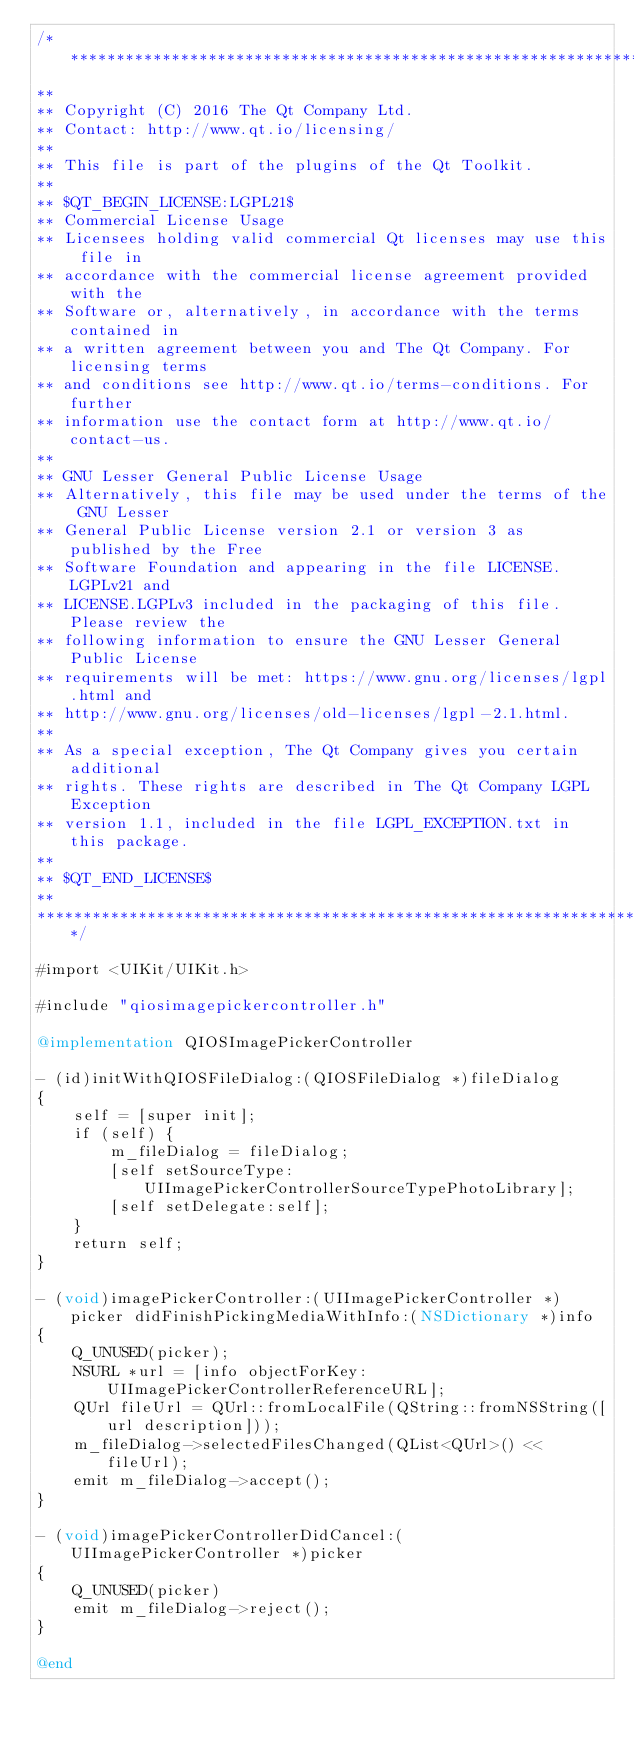<code> <loc_0><loc_0><loc_500><loc_500><_ObjectiveC_>/****************************************************************************
**
** Copyright (C) 2016 The Qt Company Ltd.
** Contact: http://www.qt.io/licensing/
**
** This file is part of the plugins of the Qt Toolkit.
**
** $QT_BEGIN_LICENSE:LGPL21$
** Commercial License Usage
** Licensees holding valid commercial Qt licenses may use this file in
** accordance with the commercial license agreement provided with the
** Software or, alternatively, in accordance with the terms contained in
** a written agreement between you and The Qt Company. For licensing terms
** and conditions see http://www.qt.io/terms-conditions. For further
** information use the contact form at http://www.qt.io/contact-us.
**
** GNU Lesser General Public License Usage
** Alternatively, this file may be used under the terms of the GNU Lesser
** General Public License version 2.1 or version 3 as published by the Free
** Software Foundation and appearing in the file LICENSE.LGPLv21 and
** LICENSE.LGPLv3 included in the packaging of this file. Please review the
** following information to ensure the GNU Lesser General Public License
** requirements will be met: https://www.gnu.org/licenses/lgpl.html and
** http://www.gnu.org/licenses/old-licenses/lgpl-2.1.html.
**
** As a special exception, The Qt Company gives you certain additional
** rights. These rights are described in The Qt Company LGPL Exception
** version 1.1, included in the file LGPL_EXCEPTION.txt in this package.
**
** $QT_END_LICENSE$
**
****************************************************************************/

#import <UIKit/UIKit.h>

#include "qiosimagepickercontroller.h"

@implementation QIOSImagePickerController

- (id)initWithQIOSFileDialog:(QIOSFileDialog *)fileDialog
{
    self = [super init];
    if (self) {
        m_fileDialog = fileDialog;
        [self setSourceType:UIImagePickerControllerSourceTypePhotoLibrary];
        [self setDelegate:self];
    }
    return self;
}

- (void)imagePickerController:(UIImagePickerController *)picker didFinishPickingMediaWithInfo:(NSDictionary *)info
{
    Q_UNUSED(picker);
    NSURL *url = [info objectForKey:UIImagePickerControllerReferenceURL];
    QUrl fileUrl = QUrl::fromLocalFile(QString::fromNSString([url description]));
    m_fileDialog->selectedFilesChanged(QList<QUrl>() << fileUrl);
    emit m_fileDialog->accept();
}

- (void)imagePickerControllerDidCancel:(UIImagePickerController *)picker
{
    Q_UNUSED(picker)
    emit m_fileDialog->reject();
}

@end
</code> 